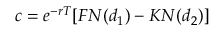Convert formula to latex. <formula><loc_0><loc_0><loc_500><loc_500>c = e ^ { - r T } [ F N ( d _ { 1 } ) - K N ( d _ { 2 } ) ]</formula> 